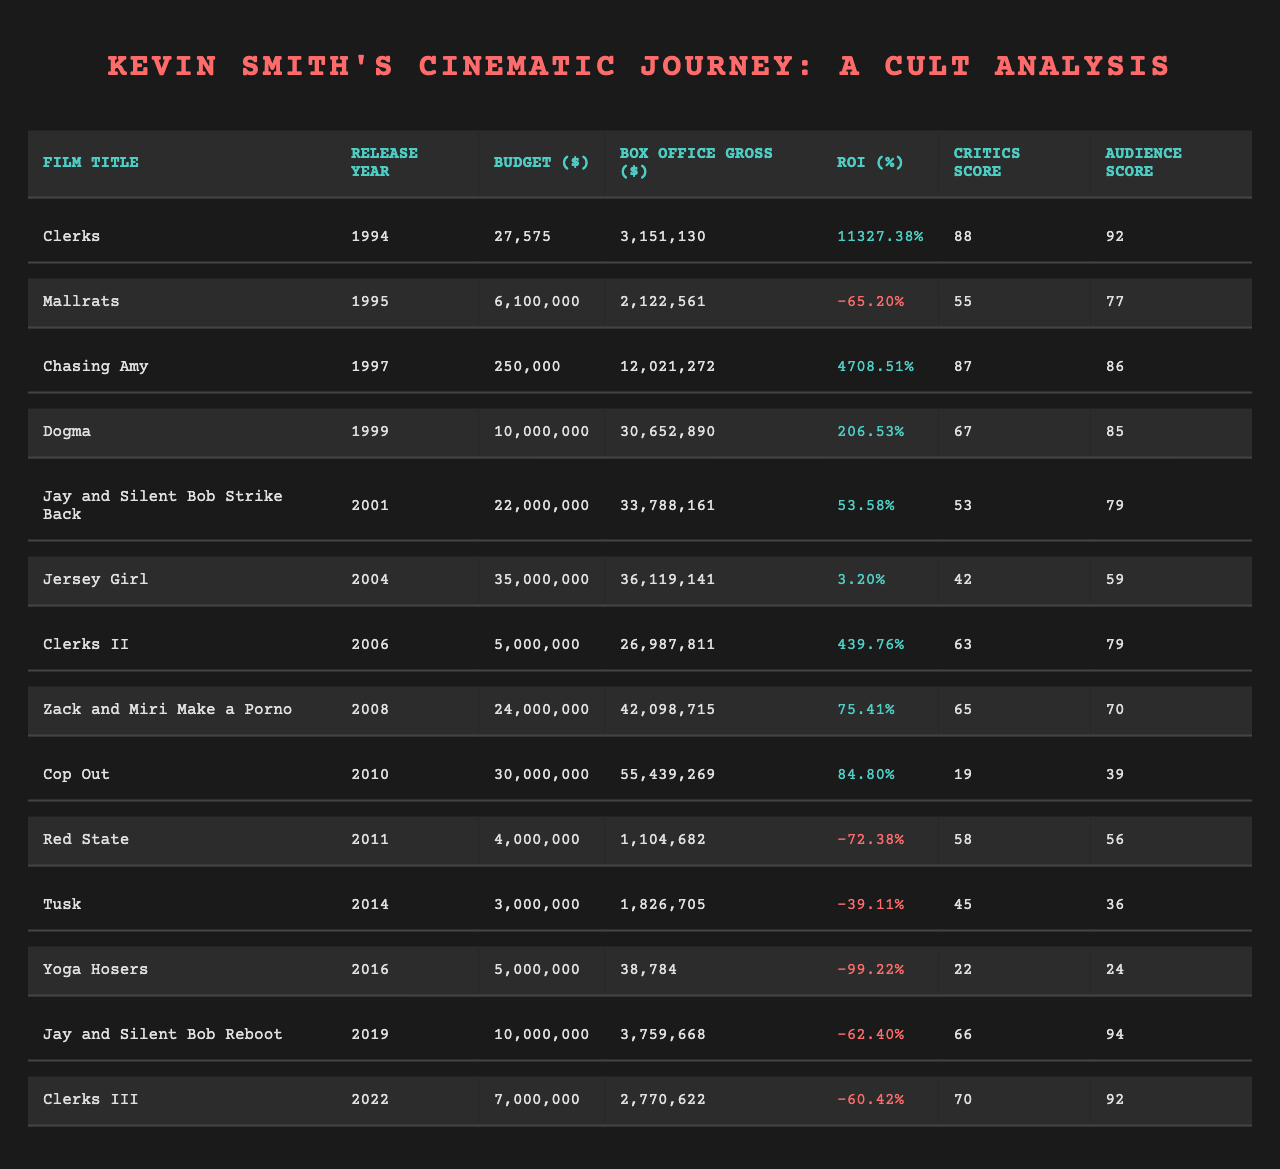What is the box office gross for "Dogma"? The table shows the box office gross for each film. For "Dogma," the value listed is 30,652,890 dollars.
Answer: 30,652,890 Which film had the highest critics score? By examining the critics scores in the table, we find that "Clerks" has the highest score of 88.
Answer: Clerks What is the average box office gross of the "Clerks" franchise films? The "Clerks" franchise films are "Clerks," "Clerks II," and "Clerks III." Their box office gross values are 3,151,130, 26,987,811, and 2,770,622 respectively. Summing these gives 3,151,130 + 26,987,811 + 2,770,622 = 32,909,563. Dividing by 3 gives an average of 32,909,563 / 3 = 10,969,854.33.
Answer: 10,969,854.33 How many films had a negative return on investment? By reviewing the table for the return on investment (ROI) values, we see that the films with negative ROI are "Mallrats," "Red State," "Tusk," "Yoga Hosers," "Jay and Silent Bob Reboot," and "Clerks III." There are 6 films in total with negative ROI.
Answer: 6 What is the difference in budget between "Chasing Amy" and "Jersey Girl"? The budget for "Chasing Amy" is 250,000 dollars while the budget for "Jersey Girl" is 35,000,000 dollars. Calculating the difference gives 35,000,000 - 250,000 = 34,750,000.
Answer: 34,750,000 True or False: "Jay and Silent Bob Strike Back" has a higher audience score than "Jersey Girl." We check the audience scores: "Jay and Silent Bob Strike Back" has a score of 79 while "Jersey Girl" has a score of 59. Since 79 is greater than 59, the statement is true.
Answer: True Which film made the lowest box office gross? The box office gross values from the table indicate that "Yoga Hosers" has the lowest gross at 38,784 dollars.
Answer: 38,784 What is the average critics score for films released after 2000? The films released after 2000 are "Jay and Silent Bob Strike Back," "Jersey Girl," "Clerks II," "Zack and Miri Make a Porno," "Cop Out," "Red State," "Tusk," "Yoga Hosers," "Jay and Silent Bob Reboot," and "Clerks III." Their critics scores are 53, 42, 63, 65, 19, 58, 45, 22, 66, and 70 respectively. Summing these gives 53 + 42 + 63 + 65 + 19 + 58 + 45 + 22 + 66 + 70 =  63.2. Then dividing by 10 gives an average of 63.2 / 10 = 63.2.
Answer: 63.2 What is the ROI of "Clerks II"? The ROI for "Clerks II" is listed in the table as 439.76%.
Answer: 439.76% Which two films have the closest box office gross? By comparing all films' box office gross, "Jay and Silent Bob Reboot" at 3,759,668 dollars and "Clerks III" at 2,770,622 dollars have the closest values. The difference is 3,759,668 - 2,770,622 = 989,046. However, the closest pair in terms of gross is "Zack and Miri Make a Porno" (42,098,715) and "Cop Out" (55,439,269) which are at a difference of 13,340,554.
Answer: Jay and Silent Bob Reboot and Clerks III What percentage of Kevin Smith's films have a box office gross of over 10 million dollars? Looking at the table, "Chasing Amy," "Dogma," "Jay and Silent Bob Strike Back," "Jersey Girl," and "Zack and Miri Make a Porno" have box office gross over 10 million dollars, out of 14 films. That gives us 5 out of 14, leading to 5 / 14 = 0.3571 or 35.71%.
Answer: 35.71% 